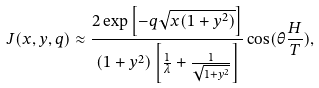Convert formula to latex. <formula><loc_0><loc_0><loc_500><loc_500>J ( x , y , q ) \approx \frac { 2 \exp \left [ - q \sqrt { x ( 1 + y ^ { 2 } ) } \right ] } { ( 1 + y ^ { 2 } ) \left [ \frac { 1 } { \lambda } + \frac { 1 } { \sqrt { 1 + y ^ { 2 } } } \right ] } \cos ( \theta \frac { H } { T } ) ,</formula> 